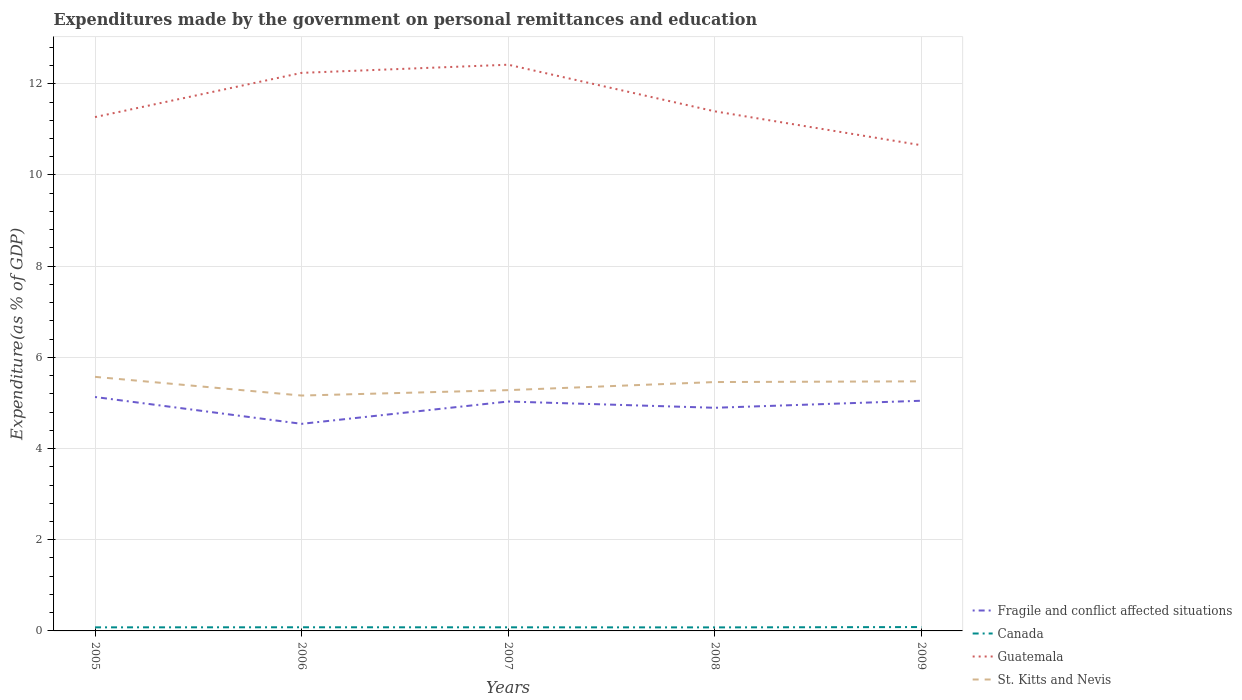How many different coloured lines are there?
Make the answer very short. 4. Across all years, what is the maximum expenditures made by the government on personal remittances and education in Fragile and conflict affected situations?
Give a very brief answer. 4.54. What is the total expenditures made by the government on personal remittances and education in Canada in the graph?
Your answer should be very brief. -0.01. What is the difference between the highest and the second highest expenditures made by the government on personal remittances and education in Guatemala?
Make the answer very short. 1.77. Is the expenditures made by the government on personal remittances and education in Fragile and conflict affected situations strictly greater than the expenditures made by the government on personal remittances and education in St. Kitts and Nevis over the years?
Offer a very short reply. Yes. Does the graph contain any zero values?
Offer a terse response. No. Where does the legend appear in the graph?
Give a very brief answer. Bottom right. How are the legend labels stacked?
Your answer should be compact. Vertical. What is the title of the graph?
Your answer should be very brief. Expenditures made by the government on personal remittances and education. What is the label or title of the X-axis?
Offer a very short reply. Years. What is the label or title of the Y-axis?
Ensure brevity in your answer.  Expenditure(as % of GDP). What is the Expenditure(as % of GDP) of Fragile and conflict affected situations in 2005?
Your response must be concise. 5.13. What is the Expenditure(as % of GDP) in Canada in 2005?
Your response must be concise. 0.08. What is the Expenditure(as % of GDP) in Guatemala in 2005?
Your answer should be very brief. 11.27. What is the Expenditure(as % of GDP) of St. Kitts and Nevis in 2005?
Provide a short and direct response. 5.57. What is the Expenditure(as % of GDP) in Fragile and conflict affected situations in 2006?
Provide a succinct answer. 4.54. What is the Expenditure(as % of GDP) of Canada in 2006?
Make the answer very short. 0.08. What is the Expenditure(as % of GDP) in Guatemala in 2006?
Keep it short and to the point. 12.24. What is the Expenditure(as % of GDP) in St. Kitts and Nevis in 2006?
Offer a terse response. 5.16. What is the Expenditure(as % of GDP) of Fragile and conflict affected situations in 2007?
Your answer should be compact. 5.03. What is the Expenditure(as % of GDP) in Canada in 2007?
Offer a terse response. 0.08. What is the Expenditure(as % of GDP) in Guatemala in 2007?
Give a very brief answer. 12.42. What is the Expenditure(as % of GDP) in St. Kitts and Nevis in 2007?
Your answer should be compact. 5.28. What is the Expenditure(as % of GDP) in Fragile and conflict affected situations in 2008?
Your answer should be compact. 4.89. What is the Expenditure(as % of GDP) of Canada in 2008?
Offer a terse response. 0.08. What is the Expenditure(as % of GDP) of Guatemala in 2008?
Give a very brief answer. 11.4. What is the Expenditure(as % of GDP) of St. Kitts and Nevis in 2008?
Your answer should be compact. 5.46. What is the Expenditure(as % of GDP) in Fragile and conflict affected situations in 2009?
Your answer should be very brief. 5.05. What is the Expenditure(as % of GDP) of Canada in 2009?
Provide a short and direct response. 0.08. What is the Expenditure(as % of GDP) of Guatemala in 2009?
Offer a very short reply. 10.65. What is the Expenditure(as % of GDP) of St. Kitts and Nevis in 2009?
Offer a very short reply. 5.47. Across all years, what is the maximum Expenditure(as % of GDP) of Fragile and conflict affected situations?
Your answer should be compact. 5.13. Across all years, what is the maximum Expenditure(as % of GDP) of Canada?
Offer a terse response. 0.08. Across all years, what is the maximum Expenditure(as % of GDP) of Guatemala?
Provide a short and direct response. 12.42. Across all years, what is the maximum Expenditure(as % of GDP) in St. Kitts and Nevis?
Keep it short and to the point. 5.57. Across all years, what is the minimum Expenditure(as % of GDP) of Fragile and conflict affected situations?
Your response must be concise. 4.54. Across all years, what is the minimum Expenditure(as % of GDP) in Canada?
Provide a short and direct response. 0.08. Across all years, what is the minimum Expenditure(as % of GDP) of Guatemala?
Provide a succinct answer. 10.65. Across all years, what is the minimum Expenditure(as % of GDP) in St. Kitts and Nevis?
Provide a succinct answer. 5.16. What is the total Expenditure(as % of GDP) in Fragile and conflict affected situations in the graph?
Provide a succinct answer. 24.65. What is the total Expenditure(as % of GDP) of Canada in the graph?
Provide a short and direct response. 0.4. What is the total Expenditure(as % of GDP) of Guatemala in the graph?
Provide a short and direct response. 57.97. What is the total Expenditure(as % of GDP) in St. Kitts and Nevis in the graph?
Provide a succinct answer. 26.95. What is the difference between the Expenditure(as % of GDP) of Fragile and conflict affected situations in 2005 and that in 2006?
Offer a terse response. 0.59. What is the difference between the Expenditure(as % of GDP) of Canada in 2005 and that in 2006?
Your response must be concise. -0. What is the difference between the Expenditure(as % of GDP) of Guatemala in 2005 and that in 2006?
Ensure brevity in your answer.  -0.97. What is the difference between the Expenditure(as % of GDP) of St. Kitts and Nevis in 2005 and that in 2006?
Provide a succinct answer. 0.41. What is the difference between the Expenditure(as % of GDP) in Fragile and conflict affected situations in 2005 and that in 2007?
Ensure brevity in your answer.  0.1. What is the difference between the Expenditure(as % of GDP) in Canada in 2005 and that in 2007?
Give a very brief answer. -0. What is the difference between the Expenditure(as % of GDP) of Guatemala in 2005 and that in 2007?
Provide a short and direct response. -1.15. What is the difference between the Expenditure(as % of GDP) of St. Kitts and Nevis in 2005 and that in 2007?
Your answer should be compact. 0.29. What is the difference between the Expenditure(as % of GDP) of Fragile and conflict affected situations in 2005 and that in 2008?
Your answer should be compact. 0.24. What is the difference between the Expenditure(as % of GDP) of Canada in 2005 and that in 2008?
Ensure brevity in your answer.  0. What is the difference between the Expenditure(as % of GDP) of Guatemala in 2005 and that in 2008?
Offer a terse response. -0.13. What is the difference between the Expenditure(as % of GDP) of St. Kitts and Nevis in 2005 and that in 2008?
Your answer should be very brief. 0.11. What is the difference between the Expenditure(as % of GDP) of Fragile and conflict affected situations in 2005 and that in 2009?
Make the answer very short. 0.08. What is the difference between the Expenditure(as % of GDP) in Canada in 2005 and that in 2009?
Keep it short and to the point. -0.01. What is the difference between the Expenditure(as % of GDP) of Guatemala in 2005 and that in 2009?
Keep it short and to the point. 0.62. What is the difference between the Expenditure(as % of GDP) in St. Kitts and Nevis in 2005 and that in 2009?
Provide a short and direct response. 0.1. What is the difference between the Expenditure(as % of GDP) of Fragile and conflict affected situations in 2006 and that in 2007?
Provide a succinct answer. -0.49. What is the difference between the Expenditure(as % of GDP) in Canada in 2006 and that in 2007?
Offer a terse response. 0. What is the difference between the Expenditure(as % of GDP) of Guatemala in 2006 and that in 2007?
Offer a very short reply. -0.18. What is the difference between the Expenditure(as % of GDP) in St. Kitts and Nevis in 2006 and that in 2007?
Offer a terse response. -0.12. What is the difference between the Expenditure(as % of GDP) of Fragile and conflict affected situations in 2006 and that in 2008?
Make the answer very short. -0.35. What is the difference between the Expenditure(as % of GDP) in Canada in 2006 and that in 2008?
Provide a succinct answer. 0. What is the difference between the Expenditure(as % of GDP) in Guatemala in 2006 and that in 2008?
Offer a very short reply. 0.84. What is the difference between the Expenditure(as % of GDP) in St. Kitts and Nevis in 2006 and that in 2008?
Your answer should be very brief. -0.3. What is the difference between the Expenditure(as % of GDP) of Fragile and conflict affected situations in 2006 and that in 2009?
Give a very brief answer. -0.51. What is the difference between the Expenditure(as % of GDP) in Canada in 2006 and that in 2009?
Offer a terse response. -0. What is the difference between the Expenditure(as % of GDP) in Guatemala in 2006 and that in 2009?
Offer a terse response. 1.59. What is the difference between the Expenditure(as % of GDP) in St. Kitts and Nevis in 2006 and that in 2009?
Offer a terse response. -0.31. What is the difference between the Expenditure(as % of GDP) of Fragile and conflict affected situations in 2007 and that in 2008?
Provide a succinct answer. 0.14. What is the difference between the Expenditure(as % of GDP) in Canada in 2007 and that in 2008?
Keep it short and to the point. 0. What is the difference between the Expenditure(as % of GDP) of Guatemala in 2007 and that in 2008?
Provide a short and direct response. 1.02. What is the difference between the Expenditure(as % of GDP) of St. Kitts and Nevis in 2007 and that in 2008?
Offer a terse response. -0.18. What is the difference between the Expenditure(as % of GDP) of Fragile and conflict affected situations in 2007 and that in 2009?
Make the answer very short. -0.02. What is the difference between the Expenditure(as % of GDP) in Canada in 2007 and that in 2009?
Ensure brevity in your answer.  -0.01. What is the difference between the Expenditure(as % of GDP) in Guatemala in 2007 and that in 2009?
Your answer should be very brief. 1.77. What is the difference between the Expenditure(as % of GDP) of St. Kitts and Nevis in 2007 and that in 2009?
Give a very brief answer. -0.19. What is the difference between the Expenditure(as % of GDP) of Fragile and conflict affected situations in 2008 and that in 2009?
Give a very brief answer. -0.15. What is the difference between the Expenditure(as % of GDP) in Canada in 2008 and that in 2009?
Keep it short and to the point. -0.01. What is the difference between the Expenditure(as % of GDP) of Guatemala in 2008 and that in 2009?
Offer a terse response. 0.74. What is the difference between the Expenditure(as % of GDP) in St. Kitts and Nevis in 2008 and that in 2009?
Provide a succinct answer. -0.02. What is the difference between the Expenditure(as % of GDP) of Fragile and conflict affected situations in 2005 and the Expenditure(as % of GDP) of Canada in 2006?
Provide a succinct answer. 5.05. What is the difference between the Expenditure(as % of GDP) of Fragile and conflict affected situations in 2005 and the Expenditure(as % of GDP) of Guatemala in 2006?
Provide a short and direct response. -7.11. What is the difference between the Expenditure(as % of GDP) of Fragile and conflict affected situations in 2005 and the Expenditure(as % of GDP) of St. Kitts and Nevis in 2006?
Keep it short and to the point. -0.03. What is the difference between the Expenditure(as % of GDP) in Canada in 2005 and the Expenditure(as % of GDP) in Guatemala in 2006?
Give a very brief answer. -12.16. What is the difference between the Expenditure(as % of GDP) in Canada in 2005 and the Expenditure(as % of GDP) in St. Kitts and Nevis in 2006?
Provide a short and direct response. -5.08. What is the difference between the Expenditure(as % of GDP) of Guatemala in 2005 and the Expenditure(as % of GDP) of St. Kitts and Nevis in 2006?
Your answer should be compact. 6.11. What is the difference between the Expenditure(as % of GDP) of Fragile and conflict affected situations in 2005 and the Expenditure(as % of GDP) of Canada in 2007?
Provide a succinct answer. 5.05. What is the difference between the Expenditure(as % of GDP) in Fragile and conflict affected situations in 2005 and the Expenditure(as % of GDP) in Guatemala in 2007?
Your answer should be compact. -7.29. What is the difference between the Expenditure(as % of GDP) of Fragile and conflict affected situations in 2005 and the Expenditure(as % of GDP) of St. Kitts and Nevis in 2007?
Ensure brevity in your answer.  -0.15. What is the difference between the Expenditure(as % of GDP) of Canada in 2005 and the Expenditure(as % of GDP) of Guatemala in 2007?
Provide a short and direct response. -12.34. What is the difference between the Expenditure(as % of GDP) of Canada in 2005 and the Expenditure(as % of GDP) of St. Kitts and Nevis in 2007?
Make the answer very short. -5.2. What is the difference between the Expenditure(as % of GDP) of Guatemala in 2005 and the Expenditure(as % of GDP) of St. Kitts and Nevis in 2007?
Provide a succinct answer. 5.99. What is the difference between the Expenditure(as % of GDP) of Fragile and conflict affected situations in 2005 and the Expenditure(as % of GDP) of Canada in 2008?
Offer a terse response. 5.05. What is the difference between the Expenditure(as % of GDP) in Fragile and conflict affected situations in 2005 and the Expenditure(as % of GDP) in Guatemala in 2008?
Your answer should be compact. -6.27. What is the difference between the Expenditure(as % of GDP) in Fragile and conflict affected situations in 2005 and the Expenditure(as % of GDP) in St. Kitts and Nevis in 2008?
Your answer should be compact. -0.33. What is the difference between the Expenditure(as % of GDP) in Canada in 2005 and the Expenditure(as % of GDP) in Guatemala in 2008?
Provide a succinct answer. -11.32. What is the difference between the Expenditure(as % of GDP) of Canada in 2005 and the Expenditure(as % of GDP) of St. Kitts and Nevis in 2008?
Your response must be concise. -5.38. What is the difference between the Expenditure(as % of GDP) in Guatemala in 2005 and the Expenditure(as % of GDP) in St. Kitts and Nevis in 2008?
Offer a very short reply. 5.81. What is the difference between the Expenditure(as % of GDP) of Fragile and conflict affected situations in 2005 and the Expenditure(as % of GDP) of Canada in 2009?
Offer a very short reply. 5.05. What is the difference between the Expenditure(as % of GDP) in Fragile and conflict affected situations in 2005 and the Expenditure(as % of GDP) in Guatemala in 2009?
Your response must be concise. -5.52. What is the difference between the Expenditure(as % of GDP) of Fragile and conflict affected situations in 2005 and the Expenditure(as % of GDP) of St. Kitts and Nevis in 2009?
Provide a short and direct response. -0.34. What is the difference between the Expenditure(as % of GDP) of Canada in 2005 and the Expenditure(as % of GDP) of Guatemala in 2009?
Offer a terse response. -10.57. What is the difference between the Expenditure(as % of GDP) of Canada in 2005 and the Expenditure(as % of GDP) of St. Kitts and Nevis in 2009?
Provide a short and direct response. -5.4. What is the difference between the Expenditure(as % of GDP) in Guatemala in 2005 and the Expenditure(as % of GDP) in St. Kitts and Nevis in 2009?
Your answer should be compact. 5.8. What is the difference between the Expenditure(as % of GDP) of Fragile and conflict affected situations in 2006 and the Expenditure(as % of GDP) of Canada in 2007?
Your response must be concise. 4.46. What is the difference between the Expenditure(as % of GDP) in Fragile and conflict affected situations in 2006 and the Expenditure(as % of GDP) in Guatemala in 2007?
Offer a very short reply. -7.88. What is the difference between the Expenditure(as % of GDP) of Fragile and conflict affected situations in 2006 and the Expenditure(as % of GDP) of St. Kitts and Nevis in 2007?
Provide a succinct answer. -0.74. What is the difference between the Expenditure(as % of GDP) in Canada in 2006 and the Expenditure(as % of GDP) in Guatemala in 2007?
Make the answer very short. -12.34. What is the difference between the Expenditure(as % of GDP) of Canada in 2006 and the Expenditure(as % of GDP) of St. Kitts and Nevis in 2007?
Provide a succinct answer. -5.2. What is the difference between the Expenditure(as % of GDP) in Guatemala in 2006 and the Expenditure(as % of GDP) in St. Kitts and Nevis in 2007?
Your answer should be very brief. 6.96. What is the difference between the Expenditure(as % of GDP) in Fragile and conflict affected situations in 2006 and the Expenditure(as % of GDP) in Canada in 2008?
Make the answer very short. 4.46. What is the difference between the Expenditure(as % of GDP) of Fragile and conflict affected situations in 2006 and the Expenditure(as % of GDP) of Guatemala in 2008?
Provide a succinct answer. -6.85. What is the difference between the Expenditure(as % of GDP) of Fragile and conflict affected situations in 2006 and the Expenditure(as % of GDP) of St. Kitts and Nevis in 2008?
Offer a very short reply. -0.92. What is the difference between the Expenditure(as % of GDP) of Canada in 2006 and the Expenditure(as % of GDP) of Guatemala in 2008?
Provide a short and direct response. -11.32. What is the difference between the Expenditure(as % of GDP) of Canada in 2006 and the Expenditure(as % of GDP) of St. Kitts and Nevis in 2008?
Offer a terse response. -5.38. What is the difference between the Expenditure(as % of GDP) of Guatemala in 2006 and the Expenditure(as % of GDP) of St. Kitts and Nevis in 2008?
Offer a terse response. 6.78. What is the difference between the Expenditure(as % of GDP) of Fragile and conflict affected situations in 2006 and the Expenditure(as % of GDP) of Canada in 2009?
Offer a very short reply. 4.46. What is the difference between the Expenditure(as % of GDP) of Fragile and conflict affected situations in 2006 and the Expenditure(as % of GDP) of Guatemala in 2009?
Provide a succinct answer. -6.11. What is the difference between the Expenditure(as % of GDP) of Fragile and conflict affected situations in 2006 and the Expenditure(as % of GDP) of St. Kitts and Nevis in 2009?
Ensure brevity in your answer.  -0.93. What is the difference between the Expenditure(as % of GDP) in Canada in 2006 and the Expenditure(as % of GDP) in Guatemala in 2009?
Ensure brevity in your answer.  -10.57. What is the difference between the Expenditure(as % of GDP) in Canada in 2006 and the Expenditure(as % of GDP) in St. Kitts and Nevis in 2009?
Provide a succinct answer. -5.39. What is the difference between the Expenditure(as % of GDP) of Guatemala in 2006 and the Expenditure(as % of GDP) of St. Kitts and Nevis in 2009?
Make the answer very short. 6.77. What is the difference between the Expenditure(as % of GDP) in Fragile and conflict affected situations in 2007 and the Expenditure(as % of GDP) in Canada in 2008?
Ensure brevity in your answer.  4.95. What is the difference between the Expenditure(as % of GDP) in Fragile and conflict affected situations in 2007 and the Expenditure(as % of GDP) in Guatemala in 2008?
Your response must be concise. -6.36. What is the difference between the Expenditure(as % of GDP) in Fragile and conflict affected situations in 2007 and the Expenditure(as % of GDP) in St. Kitts and Nevis in 2008?
Your response must be concise. -0.43. What is the difference between the Expenditure(as % of GDP) in Canada in 2007 and the Expenditure(as % of GDP) in Guatemala in 2008?
Offer a very short reply. -11.32. What is the difference between the Expenditure(as % of GDP) of Canada in 2007 and the Expenditure(as % of GDP) of St. Kitts and Nevis in 2008?
Offer a very short reply. -5.38. What is the difference between the Expenditure(as % of GDP) in Guatemala in 2007 and the Expenditure(as % of GDP) in St. Kitts and Nevis in 2008?
Your answer should be very brief. 6.96. What is the difference between the Expenditure(as % of GDP) in Fragile and conflict affected situations in 2007 and the Expenditure(as % of GDP) in Canada in 2009?
Your answer should be very brief. 4.95. What is the difference between the Expenditure(as % of GDP) of Fragile and conflict affected situations in 2007 and the Expenditure(as % of GDP) of Guatemala in 2009?
Give a very brief answer. -5.62. What is the difference between the Expenditure(as % of GDP) in Fragile and conflict affected situations in 2007 and the Expenditure(as % of GDP) in St. Kitts and Nevis in 2009?
Make the answer very short. -0.44. What is the difference between the Expenditure(as % of GDP) of Canada in 2007 and the Expenditure(as % of GDP) of Guatemala in 2009?
Keep it short and to the point. -10.57. What is the difference between the Expenditure(as % of GDP) of Canada in 2007 and the Expenditure(as % of GDP) of St. Kitts and Nevis in 2009?
Offer a terse response. -5.39. What is the difference between the Expenditure(as % of GDP) of Guatemala in 2007 and the Expenditure(as % of GDP) of St. Kitts and Nevis in 2009?
Keep it short and to the point. 6.94. What is the difference between the Expenditure(as % of GDP) of Fragile and conflict affected situations in 2008 and the Expenditure(as % of GDP) of Canada in 2009?
Your answer should be compact. 4.81. What is the difference between the Expenditure(as % of GDP) of Fragile and conflict affected situations in 2008 and the Expenditure(as % of GDP) of Guatemala in 2009?
Your answer should be very brief. -5.76. What is the difference between the Expenditure(as % of GDP) in Fragile and conflict affected situations in 2008 and the Expenditure(as % of GDP) in St. Kitts and Nevis in 2009?
Keep it short and to the point. -0.58. What is the difference between the Expenditure(as % of GDP) of Canada in 2008 and the Expenditure(as % of GDP) of Guatemala in 2009?
Give a very brief answer. -10.57. What is the difference between the Expenditure(as % of GDP) of Canada in 2008 and the Expenditure(as % of GDP) of St. Kitts and Nevis in 2009?
Keep it short and to the point. -5.4. What is the difference between the Expenditure(as % of GDP) of Guatemala in 2008 and the Expenditure(as % of GDP) of St. Kitts and Nevis in 2009?
Your answer should be compact. 5.92. What is the average Expenditure(as % of GDP) of Fragile and conflict affected situations per year?
Your answer should be compact. 4.93. What is the average Expenditure(as % of GDP) in Canada per year?
Your response must be concise. 0.08. What is the average Expenditure(as % of GDP) in Guatemala per year?
Offer a terse response. 11.59. What is the average Expenditure(as % of GDP) in St. Kitts and Nevis per year?
Give a very brief answer. 5.39. In the year 2005, what is the difference between the Expenditure(as % of GDP) in Fragile and conflict affected situations and Expenditure(as % of GDP) in Canada?
Give a very brief answer. 5.05. In the year 2005, what is the difference between the Expenditure(as % of GDP) in Fragile and conflict affected situations and Expenditure(as % of GDP) in Guatemala?
Make the answer very short. -6.14. In the year 2005, what is the difference between the Expenditure(as % of GDP) of Fragile and conflict affected situations and Expenditure(as % of GDP) of St. Kitts and Nevis?
Make the answer very short. -0.44. In the year 2005, what is the difference between the Expenditure(as % of GDP) of Canada and Expenditure(as % of GDP) of Guatemala?
Your response must be concise. -11.19. In the year 2005, what is the difference between the Expenditure(as % of GDP) of Canada and Expenditure(as % of GDP) of St. Kitts and Nevis?
Your answer should be compact. -5.49. In the year 2005, what is the difference between the Expenditure(as % of GDP) of Guatemala and Expenditure(as % of GDP) of St. Kitts and Nevis?
Give a very brief answer. 5.7. In the year 2006, what is the difference between the Expenditure(as % of GDP) in Fragile and conflict affected situations and Expenditure(as % of GDP) in Canada?
Your response must be concise. 4.46. In the year 2006, what is the difference between the Expenditure(as % of GDP) of Fragile and conflict affected situations and Expenditure(as % of GDP) of Guatemala?
Ensure brevity in your answer.  -7.7. In the year 2006, what is the difference between the Expenditure(as % of GDP) in Fragile and conflict affected situations and Expenditure(as % of GDP) in St. Kitts and Nevis?
Your answer should be compact. -0.62. In the year 2006, what is the difference between the Expenditure(as % of GDP) of Canada and Expenditure(as % of GDP) of Guatemala?
Your response must be concise. -12.16. In the year 2006, what is the difference between the Expenditure(as % of GDP) of Canada and Expenditure(as % of GDP) of St. Kitts and Nevis?
Your response must be concise. -5.08. In the year 2006, what is the difference between the Expenditure(as % of GDP) in Guatemala and Expenditure(as % of GDP) in St. Kitts and Nevis?
Make the answer very short. 7.08. In the year 2007, what is the difference between the Expenditure(as % of GDP) in Fragile and conflict affected situations and Expenditure(as % of GDP) in Canada?
Provide a short and direct response. 4.95. In the year 2007, what is the difference between the Expenditure(as % of GDP) of Fragile and conflict affected situations and Expenditure(as % of GDP) of Guatemala?
Your answer should be compact. -7.39. In the year 2007, what is the difference between the Expenditure(as % of GDP) of Fragile and conflict affected situations and Expenditure(as % of GDP) of St. Kitts and Nevis?
Your answer should be very brief. -0.25. In the year 2007, what is the difference between the Expenditure(as % of GDP) of Canada and Expenditure(as % of GDP) of Guatemala?
Give a very brief answer. -12.34. In the year 2007, what is the difference between the Expenditure(as % of GDP) in Canada and Expenditure(as % of GDP) in St. Kitts and Nevis?
Provide a succinct answer. -5.2. In the year 2007, what is the difference between the Expenditure(as % of GDP) of Guatemala and Expenditure(as % of GDP) of St. Kitts and Nevis?
Provide a short and direct response. 7.14. In the year 2008, what is the difference between the Expenditure(as % of GDP) in Fragile and conflict affected situations and Expenditure(as % of GDP) in Canada?
Offer a very short reply. 4.82. In the year 2008, what is the difference between the Expenditure(as % of GDP) of Fragile and conflict affected situations and Expenditure(as % of GDP) of Guatemala?
Offer a very short reply. -6.5. In the year 2008, what is the difference between the Expenditure(as % of GDP) in Fragile and conflict affected situations and Expenditure(as % of GDP) in St. Kitts and Nevis?
Provide a short and direct response. -0.56. In the year 2008, what is the difference between the Expenditure(as % of GDP) of Canada and Expenditure(as % of GDP) of Guatemala?
Make the answer very short. -11.32. In the year 2008, what is the difference between the Expenditure(as % of GDP) in Canada and Expenditure(as % of GDP) in St. Kitts and Nevis?
Make the answer very short. -5.38. In the year 2008, what is the difference between the Expenditure(as % of GDP) in Guatemala and Expenditure(as % of GDP) in St. Kitts and Nevis?
Offer a terse response. 5.94. In the year 2009, what is the difference between the Expenditure(as % of GDP) in Fragile and conflict affected situations and Expenditure(as % of GDP) in Canada?
Offer a very short reply. 4.96. In the year 2009, what is the difference between the Expenditure(as % of GDP) of Fragile and conflict affected situations and Expenditure(as % of GDP) of Guatemala?
Your answer should be very brief. -5.6. In the year 2009, what is the difference between the Expenditure(as % of GDP) of Fragile and conflict affected situations and Expenditure(as % of GDP) of St. Kitts and Nevis?
Make the answer very short. -0.43. In the year 2009, what is the difference between the Expenditure(as % of GDP) of Canada and Expenditure(as % of GDP) of Guatemala?
Keep it short and to the point. -10.57. In the year 2009, what is the difference between the Expenditure(as % of GDP) in Canada and Expenditure(as % of GDP) in St. Kitts and Nevis?
Keep it short and to the point. -5.39. In the year 2009, what is the difference between the Expenditure(as % of GDP) of Guatemala and Expenditure(as % of GDP) of St. Kitts and Nevis?
Your answer should be compact. 5.18. What is the ratio of the Expenditure(as % of GDP) in Fragile and conflict affected situations in 2005 to that in 2006?
Provide a succinct answer. 1.13. What is the ratio of the Expenditure(as % of GDP) of Canada in 2005 to that in 2006?
Your answer should be compact. 0.98. What is the ratio of the Expenditure(as % of GDP) in Guatemala in 2005 to that in 2006?
Offer a very short reply. 0.92. What is the ratio of the Expenditure(as % of GDP) of St. Kitts and Nevis in 2005 to that in 2006?
Provide a short and direct response. 1.08. What is the ratio of the Expenditure(as % of GDP) of Fragile and conflict affected situations in 2005 to that in 2007?
Provide a succinct answer. 1.02. What is the ratio of the Expenditure(as % of GDP) of Canada in 2005 to that in 2007?
Your response must be concise. 0.99. What is the ratio of the Expenditure(as % of GDP) of Guatemala in 2005 to that in 2007?
Your answer should be very brief. 0.91. What is the ratio of the Expenditure(as % of GDP) of St. Kitts and Nevis in 2005 to that in 2007?
Your answer should be compact. 1.06. What is the ratio of the Expenditure(as % of GDP) of Fragile and conflict affected situations in 2005 to that in 2008?
Ensure brevity in your answer.  1.05. What is the ratio of the Expenditure(as % of GDP) in Canada in 2005 to that in 2008?
Your answer should be compact. 1.01. What is the ratio of the Expenditure(as % of GDP) of Guatemala in 2005 to that in 2008?
Give a very brief answer. 0.99. What is the ratio of the Expenditure(as % of GDP) of St. Kitts and Nevis in 2005 to that in 2008?
Your answer should be compact. 1.02. What is the ratio of the Expenditure(as % of GDP) in Fragile and conflict affected situations in 2005 to that in 2009?
Give a very brief answer. 1.02. What is the ratio of the Expenditure(as % of GDP) in Canada in 2005 to that in 2009?
Make the answer very short. 0.93. What is the ratio of the Expenditure(as % of GDP) in Guatemala in 2005 to that in 2009?
Provide a succinct answer. 1.06. What is the ratio of the Expenditure(as % of GDP) in St. Kitts and Nevis in 2005 to that in 2009?
Your answer should be very brief. 1.02. What is the ratio of the Expenditure(as % of GDP) in Fragile and conflict affected situations in 2006 to that in 2007?
Offer a very short reply. 0.9. What is the ratio of the Expenditure(as % of GDP) of Canada in 2006 to that in 2007?
Offer a terse response. 1.01. What is the ratio of the Expenditure(as % of GDP) in Guatemala in 2006 to that in 2007?
Provide a succinct answer. 0.99. What is the ratio of the Expenditure(as % of GDP) in St. Kitts and Nevis in 2006 to that in 2007?
Ensure brevity in your answer.  0.98. What is the ratio of the Expenditure(as % of GDP) in Fragile and conflict affected situations in 2006 to that in 2008?
Your response must be concise. 0.93. What is the ratio of the Expenditure(as % of GDP) of Canada in 2006 to that in 2008?
Provide a succinct answer. 1.03. What is the ratio of the Expenditure(as % of GDP) in Guatemala in 2006 to that in 2008?
Make the answer very short. 1.07. What is the ratio of the Expenditure(as % of GDP) in St. Kitts and Nevis in 2006 to that in 2008?
Your response must be concise. 0.95. What is the ratio of the Expenditure(as % of GDP) in Fragile and conflict affected situations in 2006 to that in 2009?
Offer a very short reply. 0.9. What is the ratio of the Expenditure(as % of GDP) in Canada in 2006 to that in 2009?
Offer a terse response. 0.95. What is the ratio of the Expenditure(as % of GDP) in Guatemala in 2006 to that in 2009?
Your answer should be compact. 1.15. What is the ratio of the Expenditure(as % of GDP) of St. Kitts and Nevis in 2006 to that in 2009?
Your response must be concise. 0.94. What is the ratio of the Expenditure(as % of GDP) in Fragile and conflict affected situations in 2007 to that in 2008?
Ensure brevity in your answer.  1.03. What is the ratio of the Expenditure(as % of GDP) of Canada in 2007 to that in 2008?
Give a very brief answer. 1.02. What is the ratio of the Expenditure(as % of GDP) of Guatemala in 2007 to that in 2008?
Give a very brief answer. 1.09. What is the ratio of the Expenditure(as % of GDP) in St. Kitts and Nevis in 2007 to that in 2008?
Offer a very short reply. 0.97. What is the ratio of the Expenditure(as % of GDP) of Canada in 2007 to that in 2009?
Keep it short and to the point. 0.93. What is the ratio of the Expenditure(as % of GDP) in Guatemala in 2007 to that in 2009?
Make the answer very short. 1.17. What is the ratio of the Expenditure(as % of GDP) in St. Kitts and Nevis in 2007 to that in 2009?
Offer a very short reply. 0.96. What is the ratio of the Expenditure(as % of GDP) in Fragile and conflict affected situations in 2008 to that in 2009?
Offer a very short reply. 0.97. What is the ratio of the Expenditure(as % of GDP) of Canada in 2008 to that in 2009?
Provide a short and direct response. 0.92. What is the ratio of the Expenditure(as % of GDP) of Guatemala in 2008 to that in 2009?
Offer a very short reply. 1.07. What is the difference between the highest and the second highest Expenditure(as % of GDP) of Fragile and conflict affected situations?
Offer a terse response. 0.08. What is the difference between the highest and the second highest Expenditure(as % of GDP) of Canada?
Your answer should be very brief. 0. What is the difference between the highest and the second highest Expenditure(as % of GDP) of Guatemala?
Offer a very short reply. 0.18. What is the difference between the highest and the second highest Expenditure(as % of GDP) of St. Kitts and Nevis?
Make the answer very short. 0.1. What is the difference between the highest and the lowest Expenditure(as % of GDP) of Fragile and conflict affected situations?
Provide a short and direct response. 0.59. What is the difference between the highest and the lowest Expenditure(as % of GDP) of Canada?
Your answer should be very brief. 0.01. What is the difference between the highest and the lowest Expenditure(as % of GDP) of Guatemala?
Your response must be concise. 1.77. What is the difference between the highest and the lowest Expenditure(as % of GDP) in St. Kitts and Nevis?
Make the answer very short. 0.41. 